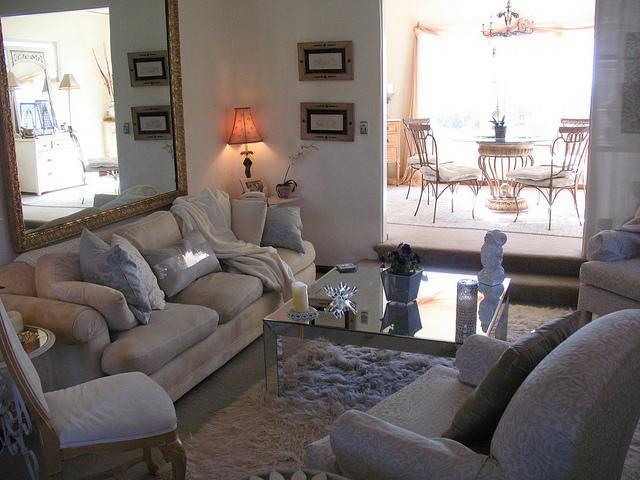Is the lamp turned on?
Be succinct. Yes. How many rooms are shown in the picture?
Quick response, please. 3. Does this room look cozy?
Quick response, please. Yes. 